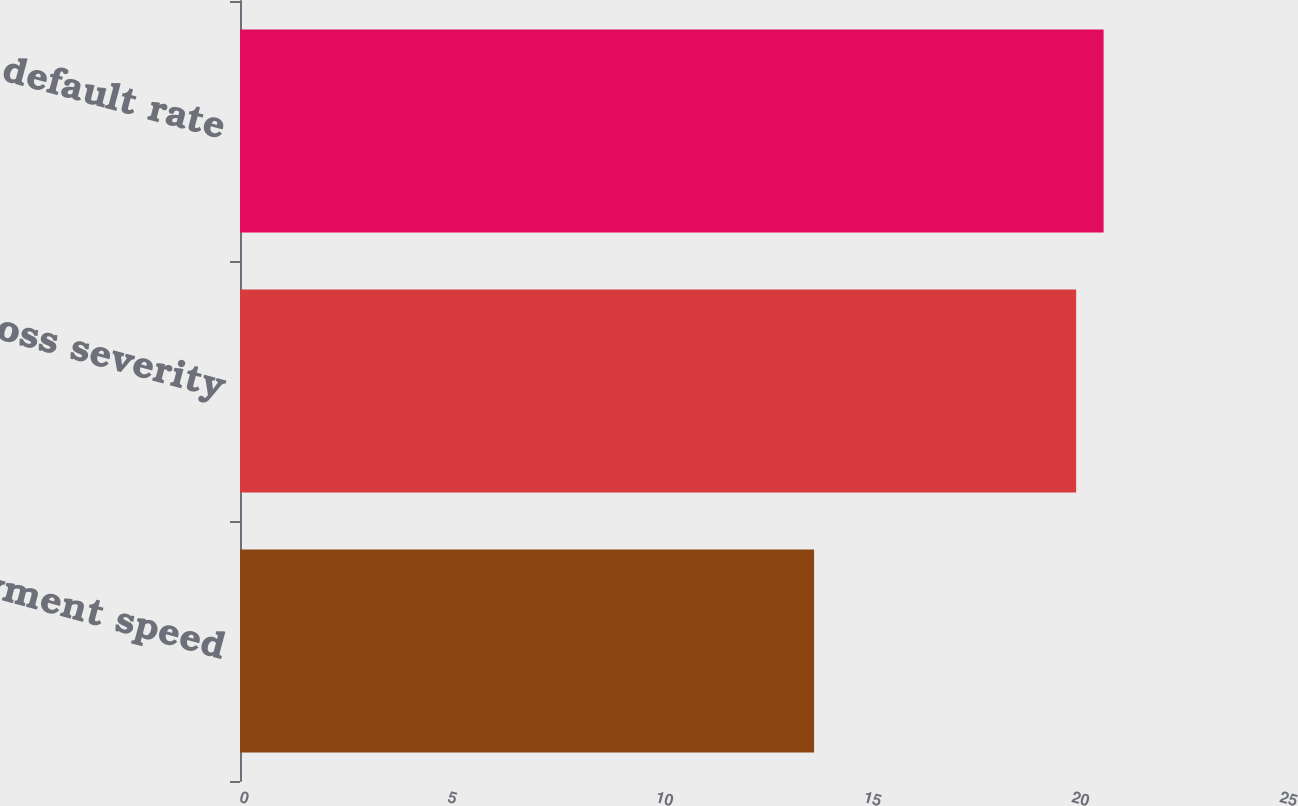Convert chart to OTSL. <chart><loc_0><loc_0><loc_500><loc_500><bar_chart><fcel>Prepayment speed<fcel>Loss severity<fcel>Life default rate<nl><fcel>13.8<fcel>20.1<fcel>20.76<nl></chart> 